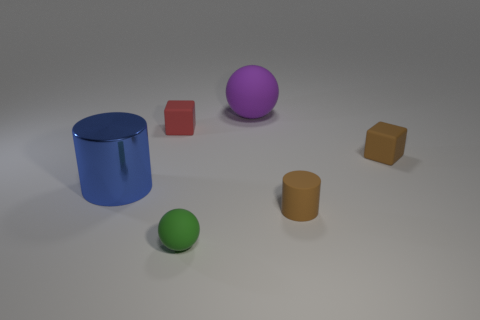What is the size of the thing that is behind the tiny brown cube and in front of the large purple thing?
Give a very brief answer. Small. There is a large thing that is to the left of the small green sphere; is its shape the same as the tiny red thing?
Ensure brevity in your answer.  No. There is a brown matte object in front of the big thing that is in front of the small rubber block left of the tiny green matte thing; how big is it?
Your answer should be very brief. Small. What size is the object that is the same color as the small matte cylinder?
Provide a succinct answer. Small. How many objects are either brown matte objects or red rubber objects?
Offer a terse response. 3. The tiny matte object that is in front of the red rubber thing and left of the big purple matte sphere has what shape?
Provide a succinct answer. Sphere. Do the tiny green rubber object and the large object right of the small green matte sphere have the same shape?
Provide a short and direct response. Yes. There is a brown cube; are there any brown objects to the left of it?
Ensure brevity in your answer.  Yes. What is the material of the thing that is the same color as the matte cylinder?
Give a very brief answer. Rubber. How many cylinders are tiny green objects or tiny things?
Give a very brief answer. 1. 